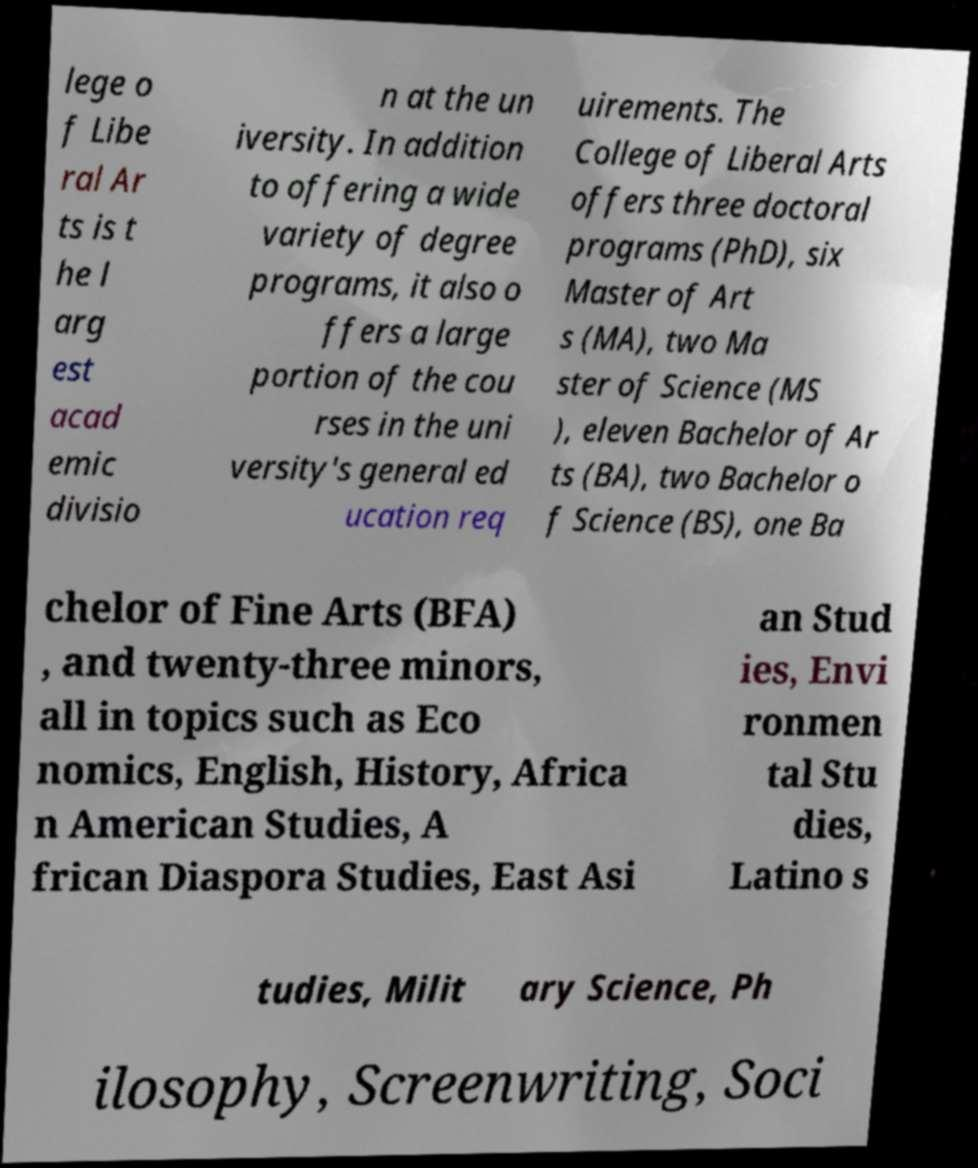Could you assist in decoding the text presented in this image and type it out clearly? lege o f Libe ral Ar ts is t he l arg est acad emic divisio n at the un iversity. In addition to offering a wide variety of degree programs, it also o ffers a large portion of the cou rses in the uni versity's general ed ucation req uirements. The College of Liberal Arts offers three doctoral programs (PhD), six Master of Art s (MA), two Ma ster of Science (MS ), eleven Bachelor of Ar ts (BA), two Bachelor o f Science (BS), one Ba chelor of Fine Arts (BFA) , and twenty-three minors, all in topics such as Eco nomics, English, History, Africa n American Studies, A frican Diaspora Studies, East Asi an Stud ies, Envi ronmen tal Stu dies, Latino s tudies, Milit ary Science, Ph ilosophy, Screenwriting, Soci 